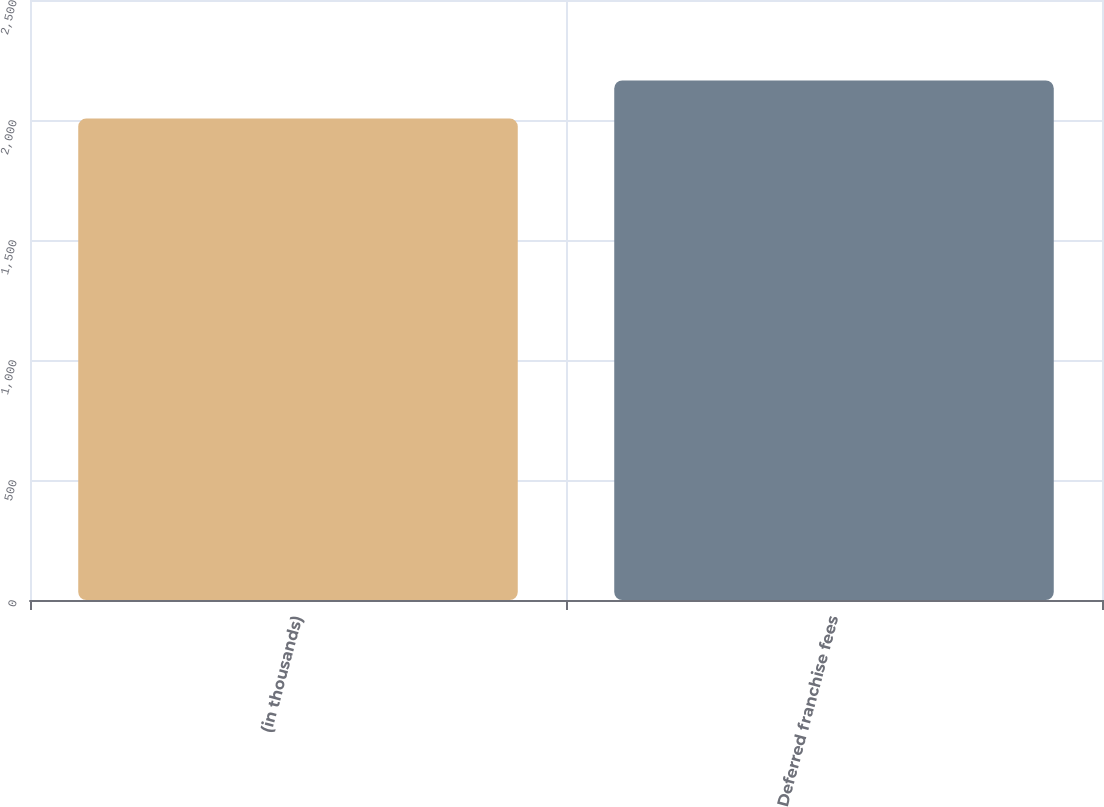Convert chart. <chart><loc_0><loc_0><loc_500><loc_500><bar_chart><fcel>(in thousands)<fcel>Deferred franchise fees<nl><fcel>2006<fcel>2165<nl></chart> 